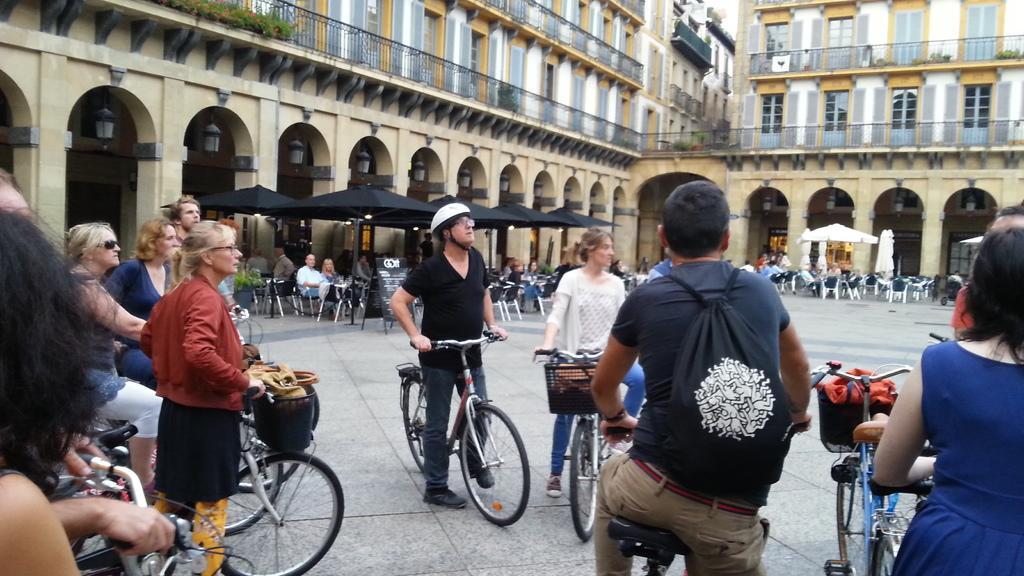Describe this image in one or two sentences. In this image, There are some people standing and holding the bicycles and in the background there are some chairs and there are some walls which are in yellow color. 